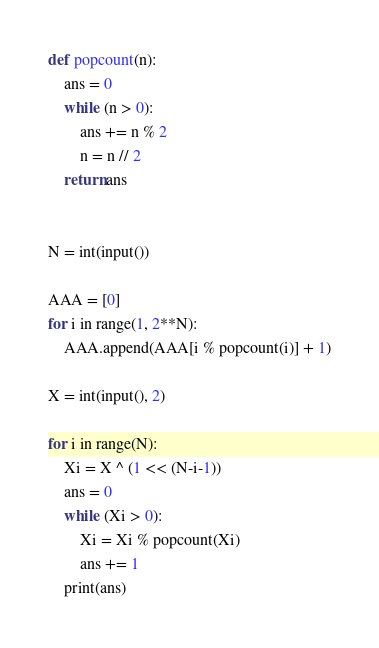<code> <loc_0><loc_0><loc_500><loc_500><_Python_>def popcount(n):
    ans = 0
    while (n > 0):
        ans += n % 2
        n = n // 2
    return ans


N = int(input())

AAA = [0]
for i in range(1, 2**N):
    AAA.append(AAA[i % popcount(i)] + 1)

X = int(input(), 2)

for i in range(N):
    Xi = X ^ (1 << (N-i-1))
    ans = 0
    while (Xi > 0):
        Xi = Xi % popcount(Xi)
        ans += 1
    print(ans)
</code> 